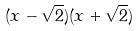Convert formula to latex. <formula><loc_0><loc_0><loc_500><loc_500>( x - \sqrt { 2 } ) ( x + \sqrt { 2 } )</formula> 